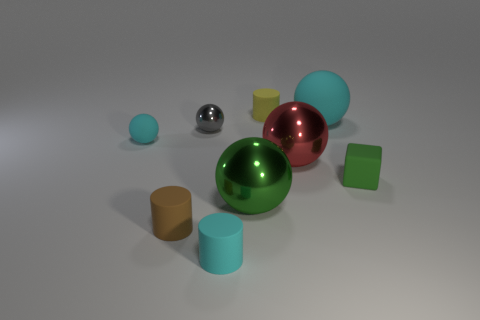There is a tiny matte cylinder behind the small ball left of the tiny brown object; how many small cylinders are on the left side of it?
Provide a succinct answer. 2. There is a big sphere that is to the right of the red object; is it the same color as the rubber ball that is to the left of the tiny cyan cylinder?
Ensure brevity in your answer.  Yes. What color is the matte cylinder that is behind the small cyan cylinder and in front of the small green rubber thing?
Provide a short and direct response. Brown. What number of brown cylinders have the same size as the yellow matte object?
Offer a very short reply. 1. What shape is the cyan object that is to the right of the large sphere that is in front of the green rubber thing?
Offer a terse response. Sphere. There is a cyan thing on the left side of the tiny cyan rubber thing that is in front of the cyan rubber sphere that is on the left side of the tiny cyan matte cylinder; what is its shape?
Your response must be concise. Sphere. How many other objects have the same shape as the brown thing?
Give a very brief answer. 2. There is a large ball to the left of the small yellow cylinder; what number of matte cylinders are on the right side of it?
Your response must be concise. 1. What number of metallic things are big green spheres or small blocks?
Keep it short and to the point. 1. Are there any large purple cylinders made of the same material as the big cyan sphere?
Your answer should be compact. No. 